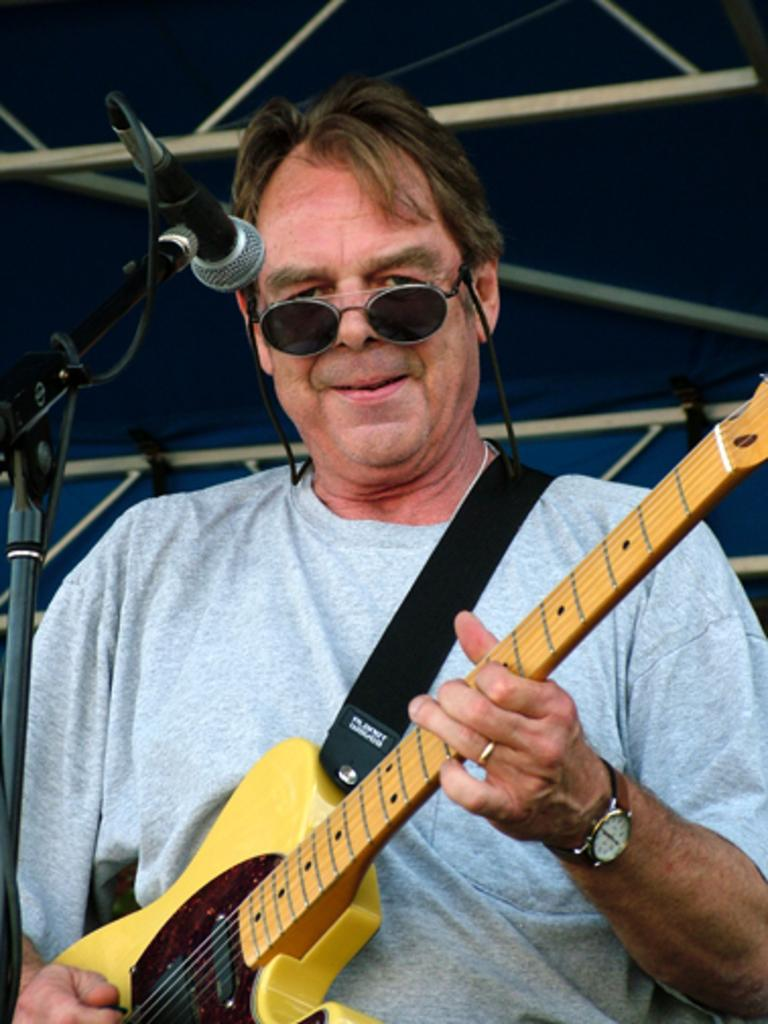Who is the main subject in the image? There is a man in the image. What is the man doing in the image? The man is standing and playing the guitar. How is the man holding the guitar? The man is holding the guitar with his left hand. What is the man doing with his right hand? The man is playing the guitar with his right hand. What type of bells can be heard ringing in the image? There are no bells present in the image, and therefore no sound can be heard. 